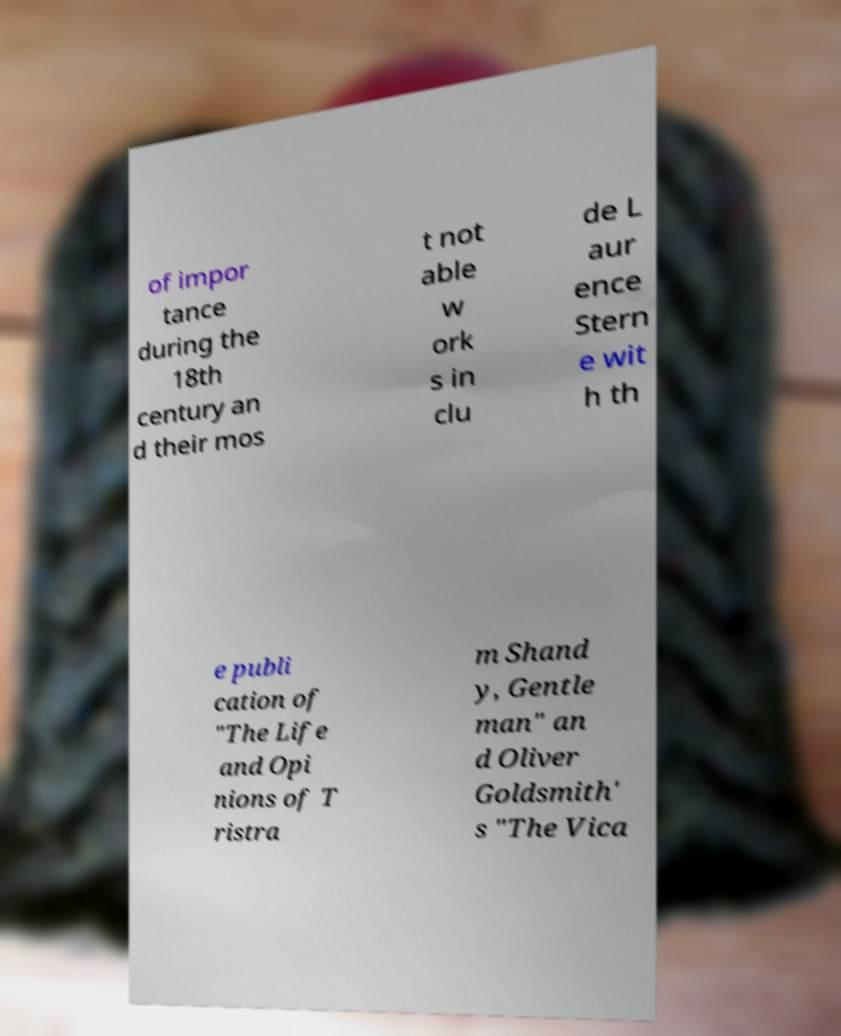I need the written content from this picture converted into text. Can you do that? of impor tance during the 18th century an d their mos t not able w ork s in clu de L aur ence Stern e wit h th e publi cation of "The Life and Opi nions of T ristra m Shand y, Gentle man" an d Oliver Goldsmith' s "The Vica 